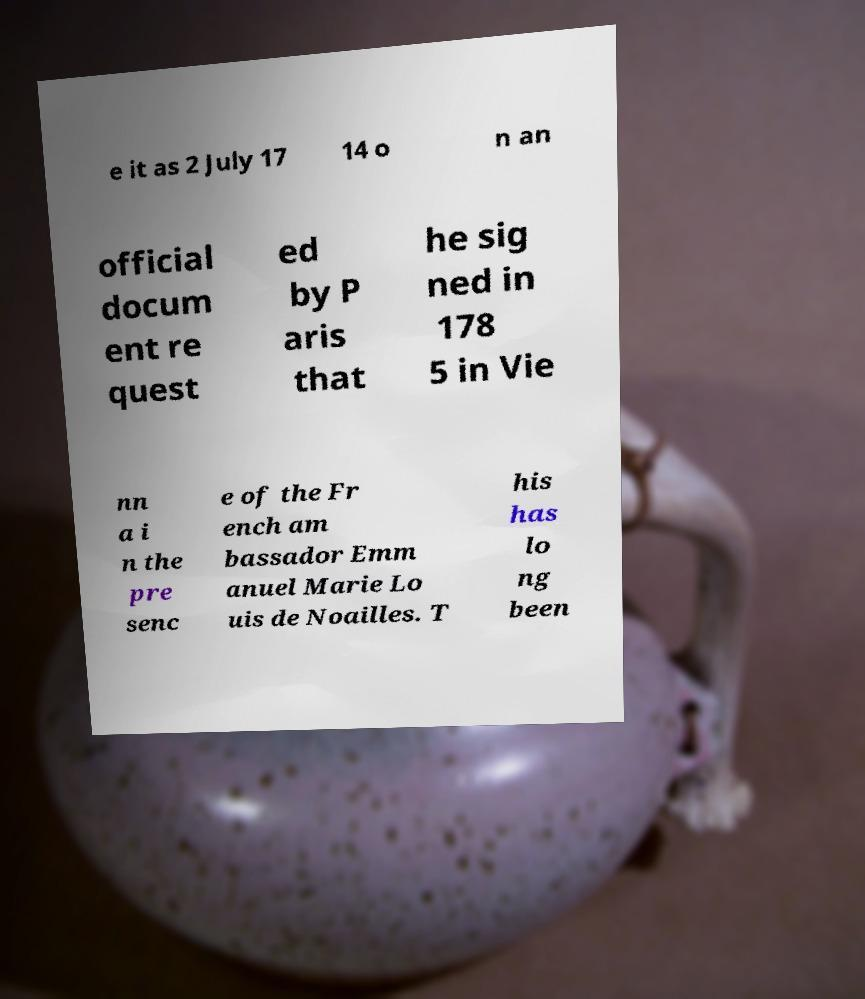Please identify and transcribe the text found in this image. e it as 2 July 17 14 o n an official docum ent re quest ed by P aris that he sig ned in 178 5 in Vie nn a i n the pre senc e of the Fr ench am bassador Emm anuel Marie Lo uis de Noailles. T his has lo ng been 